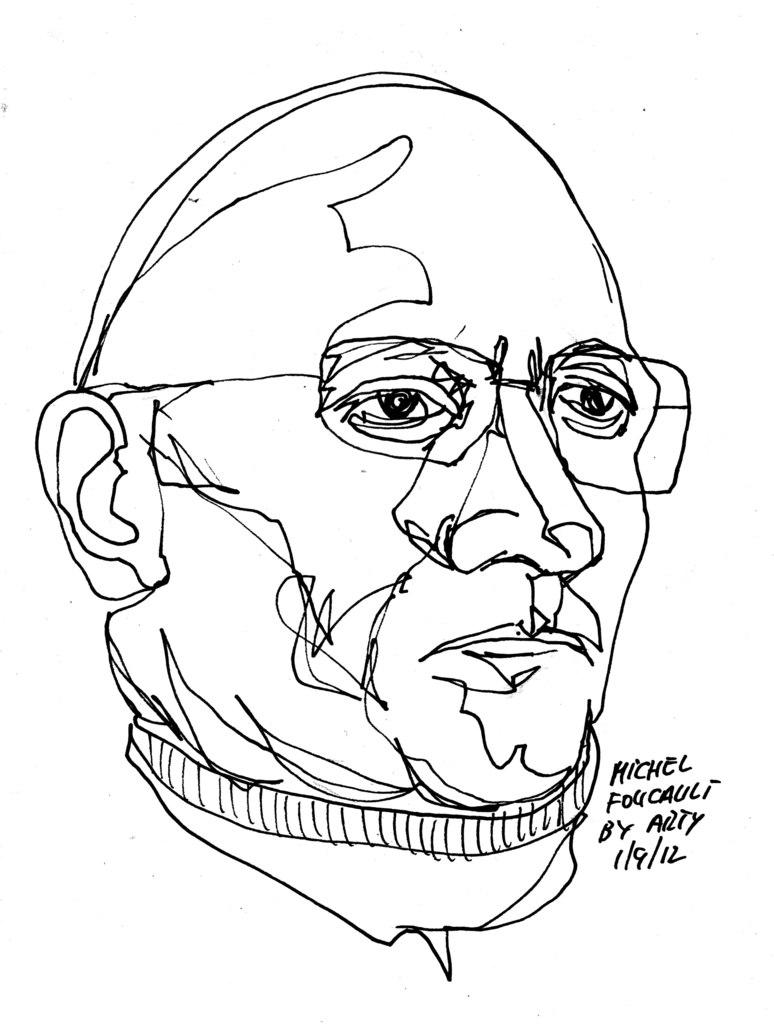What is the main subject of the image? The main subject of the image is a sketch of a person. What else is present in the image besides the sketch? There is text beside the sketch of the person. What type of cheese is being used to draw the veins in the image? There is no cheese or veins present in the image; it features a sketch of a person with accompanying text. 